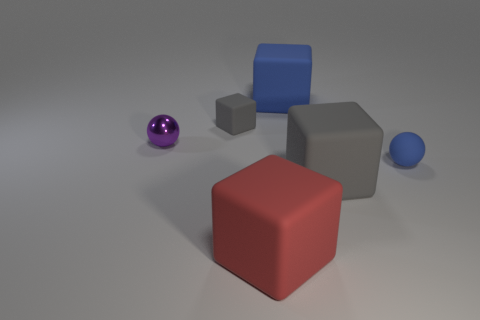Subtract 1 cubes. How many cubes are left? 3 Add 1 purple shiny things. How many objects exist? 7 Subtract all blocks. How many objects are left? 2 Add 1 red rubber blocks. How many red rubber blocks are left? 2 Add 4 large green matte things. How many large green matte things exist? 4 Subtract 0 yellow cylinders. How many objects are left? 6 Subtract all blue metal cubes. Subtract all large blue rubber objects. How many objects are left? 5 